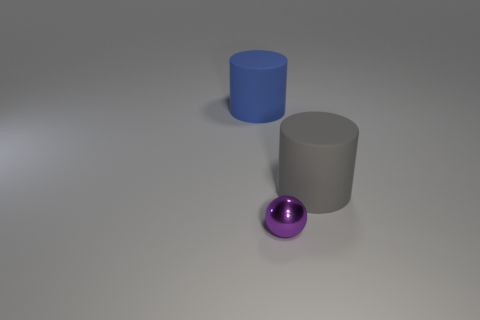Are there any other things that are the same size as the metal ball?
Provide a succinct answer. No. How many large red matte balls are there?
Make the answer very short. 0. Are there more big blue things in front of the metallic ball than large blue matte cylinders?
Ensure brevity in your answer.  No. What material is the cylinder that is to the right of the small metal ball?
Your response must be concise. Rubber. There is another big matte object that is the same shape as the big blue object; what is its color?
Your answer should be very brief. Gray. Do the rubber object in front of the large blue matte object and the object in front of the big gray rubber cylinder have the same size?
Make the answer very short. No. There is a blue thing; is its size the same as the purple metallic thing on the left side of the gray cylinder?
Your response must be concise. No. What size is the blue thing?
Give a very brief answer. Large. What color is the large cylinder that is the same material as the big blue object?
Offer a terse response. Gray. What number of other big objects are the same material as the big gray object?
Offer a terse response. 1. 